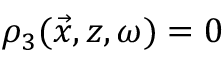Convert formula to latex. <formula><loc_0><loc_0><loc_500><loc_500>\rho _ { 3 } ( \vec { x } , z , \omega ) = 0</formula> 